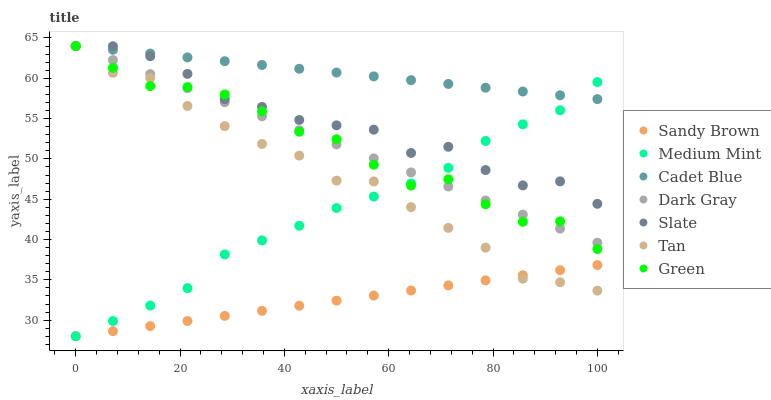Does Sandy Brown have the minimum area under the curve?
Answer yes or no. Yes. Does Cadet Blue have the maximum area under the curve?
Answer yes or no. Yes. Does Slate have the minimum area under the curve?
Answer yes or no. No. Does Slate have the maximum area under the curve?
Answer yes or no. No. Is Cadet Blue the smoothest?
Answer yes or no. Yes. Is Slate the roughest?
Answer yes or no. Yes. Is Slate the smoothest?
Answer yes or no. No. Is Cadet Blue the roughest?
Answer yes or no. No. Does Medium Mint have the lowest value?
Answer yes or no. Yes. Does Slate have the lowest value?
Answer yes or no. No. Does Tan have the highest value?
Answer yes or no. Yes. Does Sandy Brown have the highest value?
Answer yes or no. No. Is Sandy Brown less than Slate?
Answer yes or no. Yes. Is Cadet Blue greater than Sandy Brown?
Answer yes or no. Yes. Does Green intersect Cadet Blue?
Answer yes or no. Yes. Is Green less than Cadet Blue?
Answer yes or no. No. Is Green greater than Cadet Blue?
Answer yes or no. No. Does Sandy Brown intersect Slate?
Answer yes or no. No. 